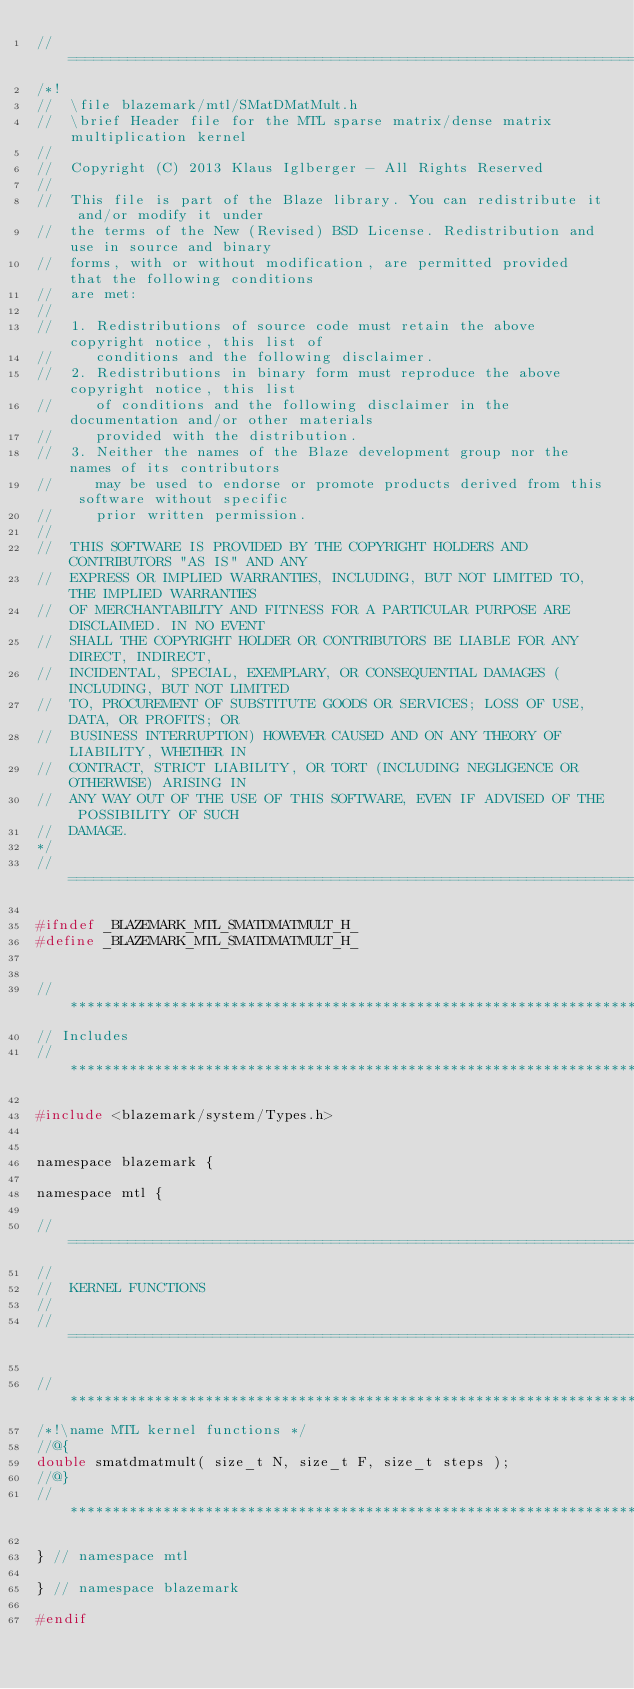<code> <loc_0><loc_0><loc_500><loc_500><_C_>//=================================================================================================
/*!
//  \file blazemark/mtl/SMatDMatMult.h
//  \brief Header file for the MTL sparse matrix/dense matrix multiplication kernel
//
//  Copyright (C) 2013 Klaus Iglberger - All Rights Reserved
//
//  This file is part of the Blaze library. You can redistribute it and/or modify it under
//  the terms of the New (Revised) BSD License. Redistribution and use in source and binary
//  forms, with or without modification, are permitted provided that the following conditions
//  are met:
//
//  1. Redistributions of source code must retain the above copyright notice, this list of
//     conditions and the following disclaimer.
//  2. Redistributions in binary form must reproduce the above copyright notice, this list
//     of conditions and the following disclaimer in the documentation and/or other materials
//     provided with the distribution.
//  3. Neither the names of the Blaze development group nor the names of its contributors
//     may be used to endorse or promote products derived from this software without specific
//     prior written permission.
//
//  THIS SOFTWARE IS PROVIDED BY THE COPYRIGHT HOLDERS AND CONTRIBUTORS "AS IS" AND ANY
//  EXPRESS OR IMPLIED WARRANTIES, INCLUDING, BUT NOT LIMITED TO, THE IMPLIED WARRANTIES
//  OF MERCHANTABILITY AND FITNESS FOR A PARTICULAR PURPOSE ARE DISCLAIMED. IN NO EVENT
//  SHALL THE COPYRIGHT HOLDER OR CONTRIBUTORS BE LIABLE FOR ANY DIRECT, INDIRECT,
//  INCIDENTAL, SPECIAL, EXEMPLARY, OR CONSEQUENTIAL DAMAGES (INCLUDING, BUT NOT LIMITED
//  TO, PROCUREMENT OF SUBSTITUTE GOODS OR SERVICES; LOSS OF USE, DATA, OR PROFITS; OR
//  BUSINESS INTERRUPTION) HOWEVER CAUSED AND ON ANY THEORY OF LIABILITY, WHETHER IN
//  CONTRACT, STRICT LIABILITY, OR TORT (INCLUDING NEGLIGENCE OR OTHERWISE) ARISING IN
//  ANY WAY OUT OF THE USE OF THIS SOFTWARE, EVEN IF ADVISED OF THE POSSIBILITY OF SUCH
//  DAMAGE.
*/
//=================================================================================================

#ifndef _BLAZEMARK_MTL_SMATDMATMULT_H_
#define _BLAZEMARK_MTL_SMATDMATMULT_H_


//*************************************************************************************************
// Includes
//*************************************************************************************************

#include <blazemark/system/Types.h>


namespace blazemark {

namespace mtl {

//=================================================================================================
//
//  KERNEL FUNCTIONS
//
//=================================================================================================

//*************************************************************************************************
/*!\name MTL kernel functions */
//@{
double smatdmatmult( size_t N, size_t F, size_t steps );
//@}
//*************************************************************************************************

} // namespace mtl

} // namespace blazemark

#endif
</code> 